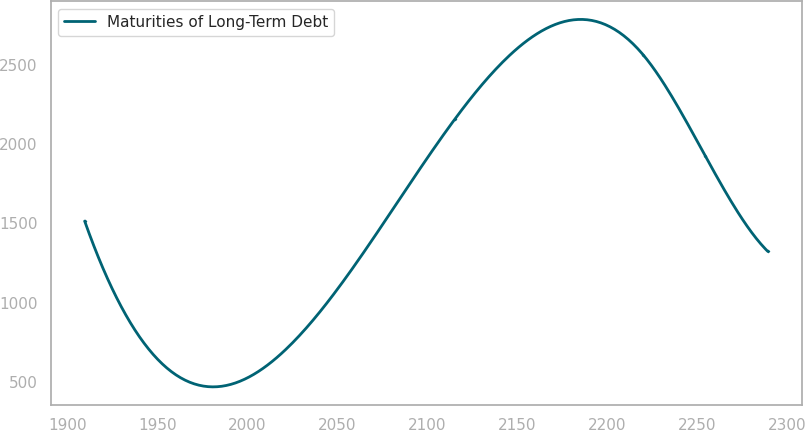<chart> <loc_0><loc_0><loc_500><loc_500><line_chart><ecel><fcel>Maturities of Long-Term Debt<nl><fcel>1909.65<fcel>1514.58<nl><fcel>2115.52<fcel>2161.24<nl><fcel>2219.91<fcel>2564.69<nl><fcel>2254.52<fcel>1924.65<nl><fcel>2289.13<fcel>1323.73<nl></chart> 